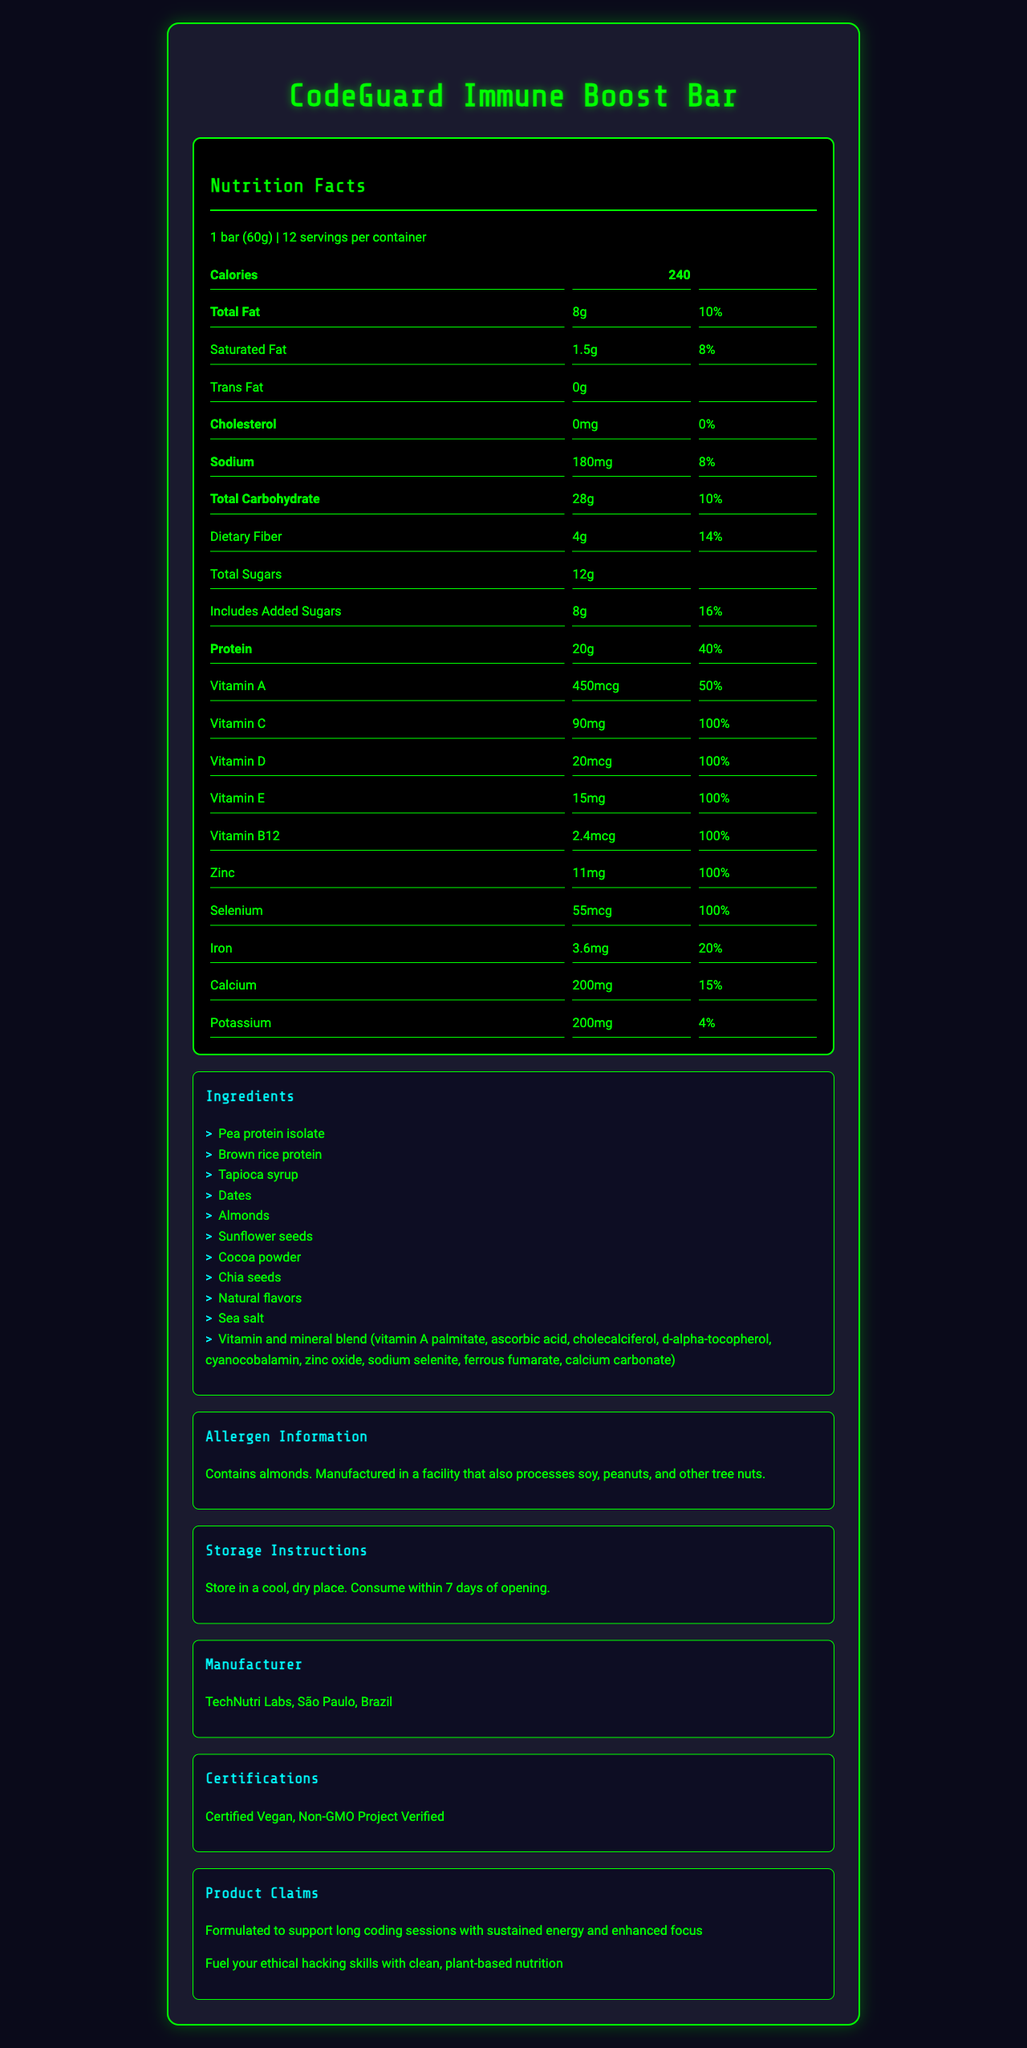what is the serving size? The document specifies that the serving size for the CodeGuard Immune Boost Bar is 1 bar, which weighs 60 grams.
Answer: 1 bar (60g) how many servings are there per container? The document states there are 12 servings per container.
Answer: 12 how many calories are in one serving? The nutrition label shows that there are 240 calories in one serving.
Answer: 240 which vitamins are provided at 100% of the daily value? The nutrition facts list these vitamins and minerals with a daily value of 100%.
Answer: Vitamin C, Vitamin D, Vitamin E, Vitamin B12, Zinc, Selenium what is the amount of protein per serving? The document specifies that each serving contains 20 grams of protein.
Answer: 20g how much dietary fiber is in one bar? According to the document, each bar has 4 grams of dietary fiber.
Answer: 4g how much sodium does one serving contain? A. 200mg B. 180mg C. 210mg D. 220mg The nutrition label states that each serving contains 180mg of sodium.
Answer: B what is the amount of calcium in one serving? A. 150mg B. 100mg C. 200mg D. 250mg The nutrient list indicates that there are 200mg of calcium in one serving.
Answer: C does the product contain any peanuts? The allergen information states that the product contains almonds and is manufactured in a facility that processes soy, peanuts, and other tree nuts, but does not explicitly contain peanuts.
Answer: No is the product suitable for vegetarians? The product is certified vegan, according to the certification section, making it suitable for vegetarians.
Answer: Yes summarize the main features of the CodeGuard Immune Boost Bar. The document details the nutrition facts, ingredients, allergen information, storage instructions, manufacturer, certifications, and product claims of the CodeGuard Immune Boost Bar. The bar is formulated to support long coding sessions with sustained energy and enhanced focus while providing essential vitamins and minerals for immune support.
Answer: The CodeGuard Immune Boost Bar is a fortified vegetarian protein bar designed to support immune function during long coding sessions. Each bar provides 240 calories, 20 grams of protein, and significant amounts of essential vitamins and minerals such as Vitamin C, D, E, B12, Zinc, and Selenium. The product is vegan, Non-GMO, and contains almonds. It is manufactured by TechNutri Labs in São Paulo, Brazil, and aims to offer sustained energy and enhanced focus for ethical hacking and coding. who manufactures the CodeGuard Immune Boost Bar? The manufacturer information is provided in the document.
Answer: TechNutri Labs, São Paulo, Brazil what is the daily value percentage of iron provided by one bar? The nutrition label indicates that one bar provides 20% of the daily value for iron.
Answer: 20% how much total fat is in one serving? The document states that there is a total of 8 grams of fat per serving.
Answer: 8g what are the first three ingredients listed? Ingredients are listed in order of quantity, and these are the first three ingredients.
Answer: Pea protein isolate, Brown rice protein, Tapioca syrup how should the product be stored? The storage instructions are provided in the document.
Answer: Store in a cool, dry place. Consume within 7 days of opening. what kind of vitamins are included in the product? A. Only B-vitamins B. Vitamins and minerals C. Only minerals The product contains a blend of vitamins and minerals, as stated in the ingredients and nutrient list.
Answer: B does the bar contain any added sugars? The document specifies that the bar includes 8 grams of added sugars.
Answer: Yes is the product safe for people with peanut allergies? While the product contains almonds and is manufactured in a facility that processes peanuts, there is no explicit information on whether cross-contamination with peanuts can be avoided. Therefore, it isn't safe to assume it's entirely peanut-free without further information.
Answer: Cannot be determined how does the bar claim to support coding sessions? The document includes a section about product claims, stating that the bar is formulated to support long coding sessions with sustained energy and enhanced focus.
Answer: Formulated to support long coding sessions with sustained energy and enhanced focus 